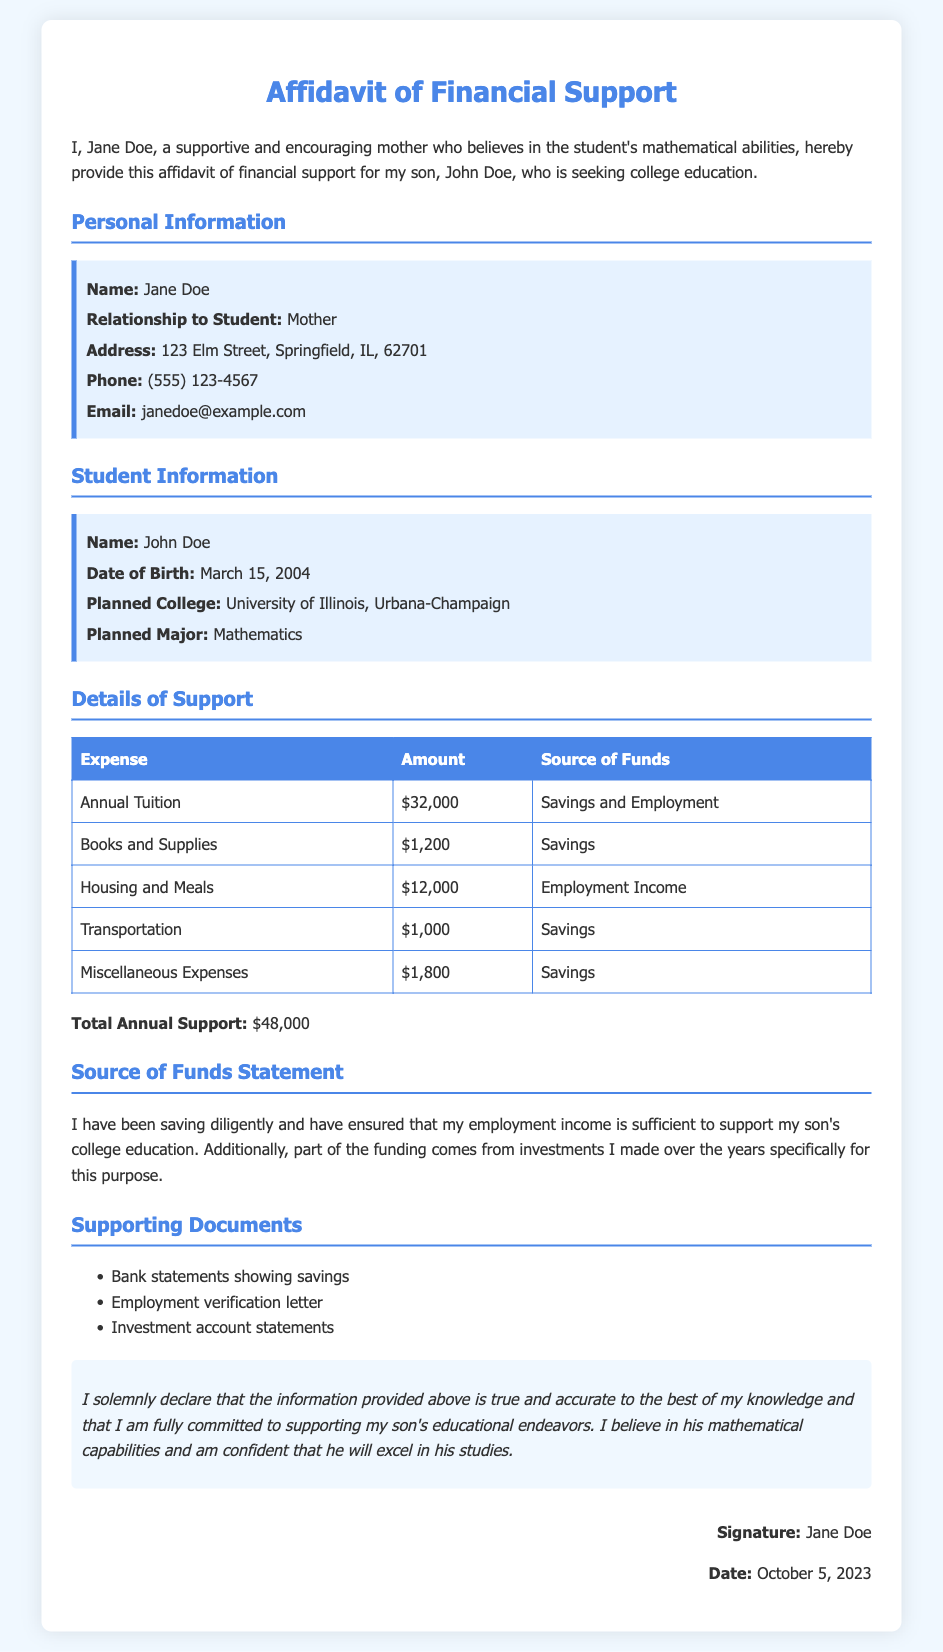What is the name of the mother supporting the student? The document states that the mother's name is Jane Doe.
Answer: Jane Doe What is the planned major of the student? It is mentioned in the document that John Doe plans to major in Mathematics.
Answer: Mathematics How much is the annual tuition for the college education? The document lists the annual tuition as $32,000.
Answer: $32,000 What is the total annual support amount provided? The document calculates the total annual support as $48,000 from various expenses.
Answer: $48,000 What is the source of funds for Books and Supplies? The document specifies that the source of funds for Books and Supplies is Savings.
Answer: Savings What is the relationship of Jane Doe to John Doe? The document clearly identifies Jane Doe as the Mother of John Doe.
Answer: Mother Which college is John Doe planning to attend? The document mentions that the planned college for John Doe is University of Illinois, Urbana-Champaign.
Answer: University of Illinois, Urbana-Champaign What supporting document verifies Jane's employment? An Employment verification letter is listed in the supporting documents.
Answer: Employment verification letter What is the date of the affidavit's signature? The document indicates that the affidavit was signed on October 5, 2023.
Answer: October 5, 2023 